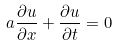<formula> <loc_0><loc_0><loc_500><loc_500>a { \frac { \partial u } { \partial x } } + { \frac { \partial u } { \partial t } } = 0</formula> 